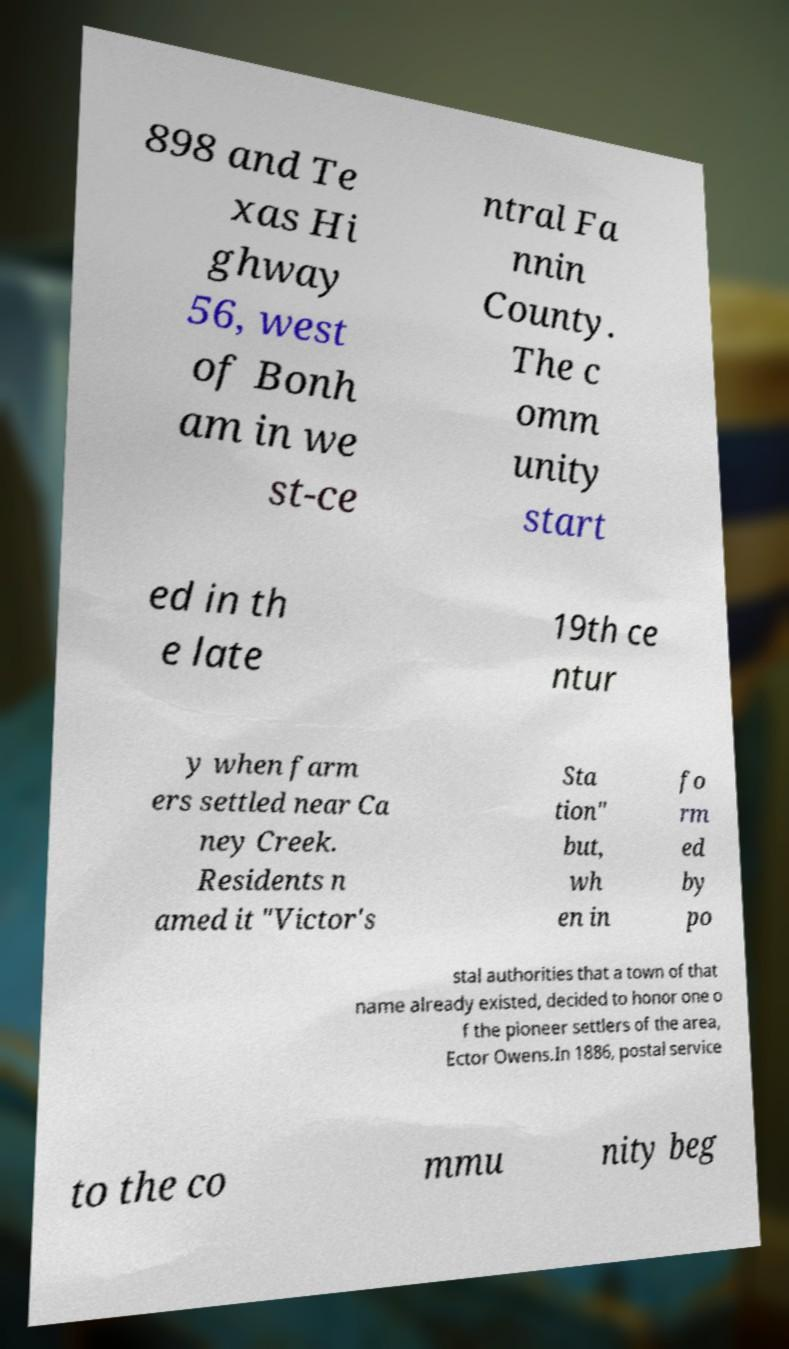Please identify and transcribe the text found in this image. 898 and Te xas Hi ghway 56, west of Bonh am in we st-ce ntral Fa nnin County. The c omm unity start ed in th e late 19th ce ntur y when farm ers settled near Ca ney Creek. Residents n amed it "Victor's Sta tion" but, wh en in fo rm ed by po stal authorities that a town of that name already existed, decided to honor one o f the pioneer settlers of the area, Ector Owens.In 1886, postal service to the co mmu nity beg 